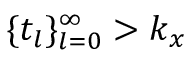<formula> <loc_0><loc_0><loc_500><loc_500>\{ t _ { l } \} _ { l = 0 } ^ { \infty } > k _ { x }</formula> 